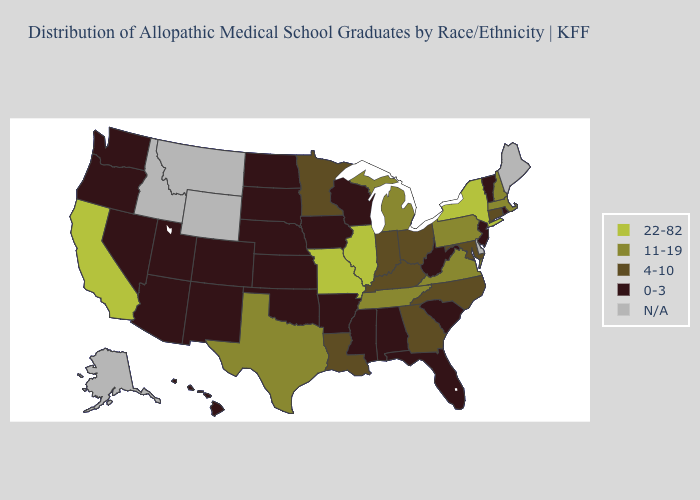Name the states that have a value in the range 22-82?
Short answer required. California, Illinois, Missouri, New York. Name the states that have a value in the range 4-10?
Answer briefly. Connecticut, Georgia, Indiana, Kentucky, Louisiana, Maryland, Minnesota, North Carolina, Ohio. Name the states that have a value in the range N/A?
Give a very brief answer. Alaska, Delaware, Idaho, Maine, Montana, Wyoming. Does California have the highest value in the West?
Be succinct. Yes. Name the states that have a value in the range 11-19?
Short answer required. Massachusetts, Michigan, New Hampshire, Pennsylvania, Tennessee, Texas, Virginia. Does Mississippi have the highest value in the South?
Answer briefly. No. Does the first symbol in the legend represent the smallest category?
Short answer required. No. Name the states that have a value in the range 4-10?
Give a very brief answer. Connecticut, Georgia, Indiana, Kentucky, Louisiana, Maryland, Minnesota, North Carolina, Ohio. Which states have the lowest value in the USA?
Be succinct. Alabama, Arizona, Arkansas, Colorado, Florida, Hawaii, Iowa, Kansas, Mississippi, Nebraska, Nevada, New Jersey, New Mexico, North Dakota, Oklahoma, Oregon, Rhode Island, South Carolina, South Dakota, Utah, Vermont, Washington, West Virginia, Wisconsin. What is the value of Rhode Island?
Answer briefly. 0-3. Name the states that have a value in the range 22-82?
Answer briefly. California, Illinois, Missouri, New York. Name the states that have a value in the range N/A?
Keep it brief. Alaska, Delaware, Idaho, Maine, Montana, Wyoming. What is the highest value in states that border Wisconsin?
Short answer required. 22-82. Which states hav the highest value in the Northeast?
Give a very brief answer. New York. 